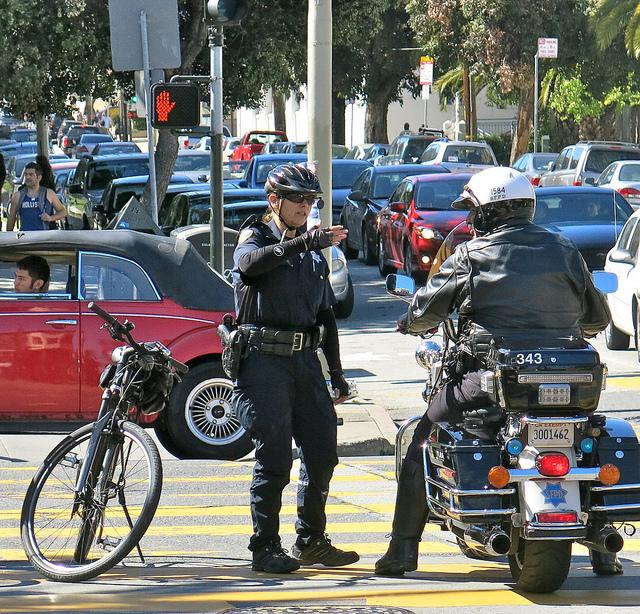What are they discussing? Please explain your reasoning. traffic. They are discussing the traffic. 